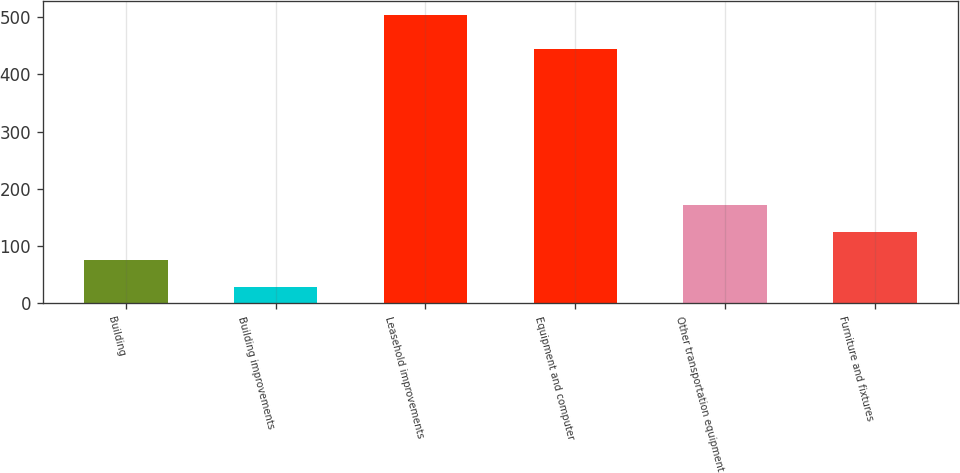Convert chart to OTSL. <chart><loc_0><loc_0><loc_500><loc_500><bar_chart><fcel>Building<fcel>Building improvements<fcel>Leasehold improvements<fcel>Equipment and computer<fcel>Other transportation equipment<fcel>Furniture and fixtures<nl><fcel>76.5<fcel>29<fcel>504<fcel>444<fcel>171.5<fcel>124<nl></chart> 